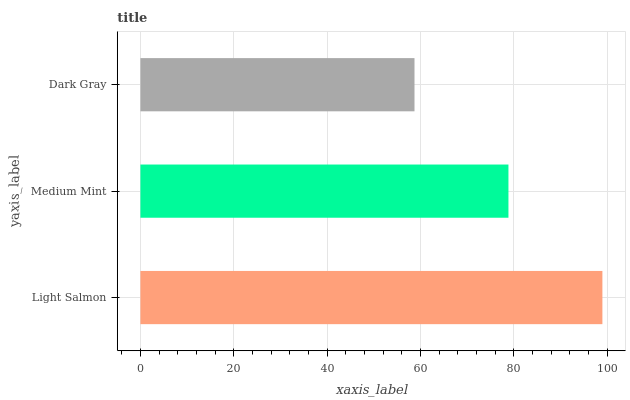Is Dark Gray the minimum?
Answer yes or no. Yes. Is Light Salmon the maximum?
Answer yes or no. Yes. Is Medium Mint the minimum?
Answer yes or no. No. Is Medium Mint the maximum?
Answer yes or no. No. Is Light Salmon greater than Medium Mint?
Answer yes or no. Yes. Is Medium Mint less than Light Salmon?
Answer yes or no. Yes. Is Medium Mint greater than Light Salmon?
Answer yes or no. No. Is Light Salmon less than Medium Mint?
Answer yes or no. No. Is Medium Mint the high median?
Answer yes or no. Yes. Is Medium Mint the low median?
Answer yes or no. Yes. Is Light Salmon the high median?
Answer yes or no. No. Is Dark Gray the low median?
Answer yes or no. No. 